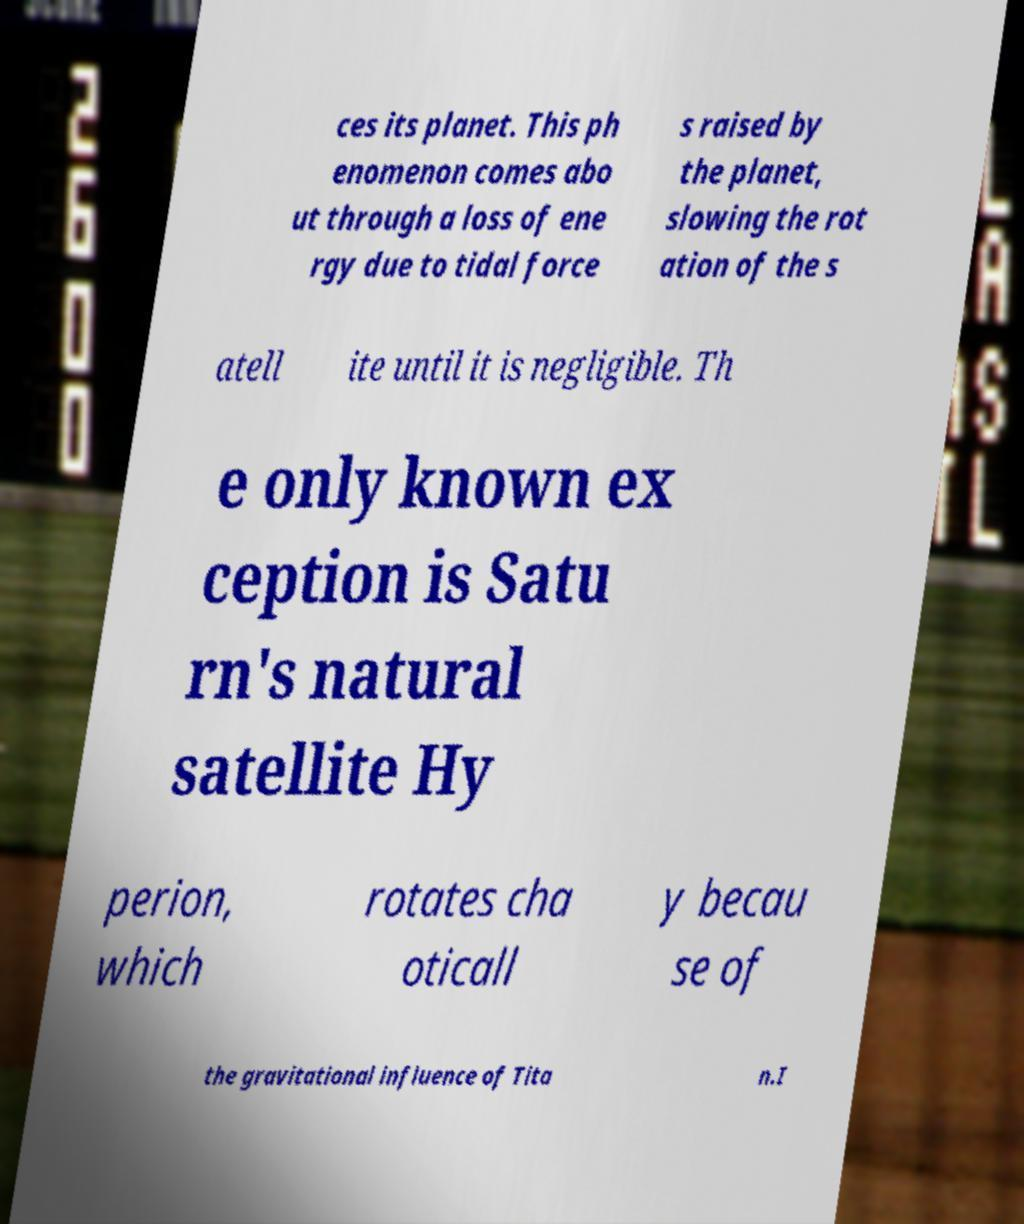I need the written content from this picture converted into text. Can you do that? ces its planet. This ph enomenon comes abo ut through a loss of ene rgy due to tidal force s raised by the planet, slowing the rot ation of the s atell ite until it is negligible. Th e only known ex ception is Satu rn's natural satellite Hy perion, which rotates cha oticall y becau se of the gravitational influence of Tita n.I 